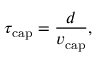<formula> <loc_0><loc_0><loc_500><loc_500>\tau _ { c a p } = \frac { d } { v _ { c a p } } ,</formula> 